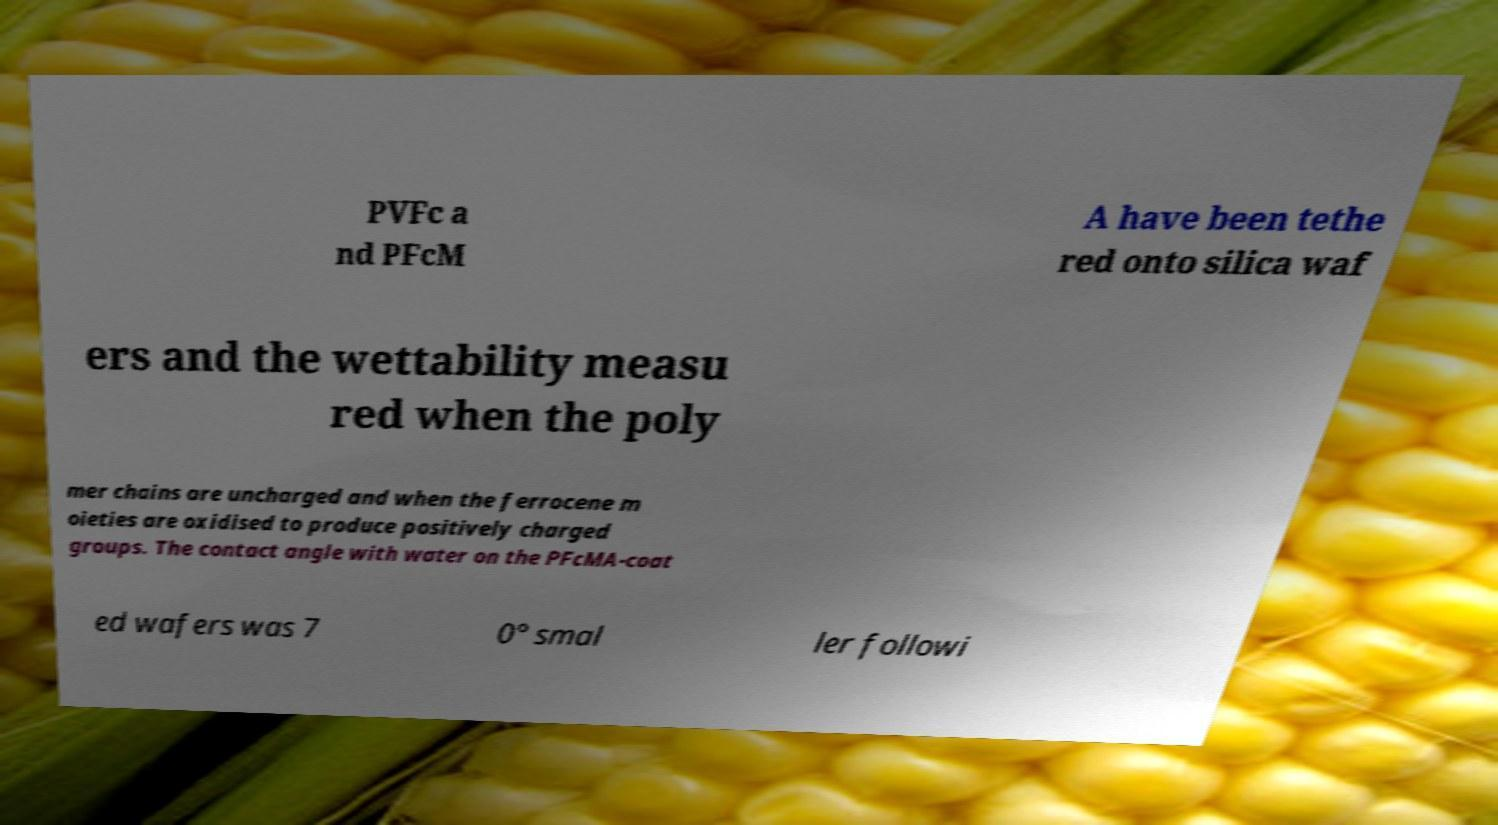I need the written content from this picture converted into text. Can you do that? PVFc a nd PFcM A have been tethe red onto silica waf ers and the wettability measu red when the poly mer chains are uncharged and when the ferrocene m oieties are oxidised to produce positively charged groups. The contact angle with water on the PFcMA-coat ed wafers was 7 0° smal ler followi 